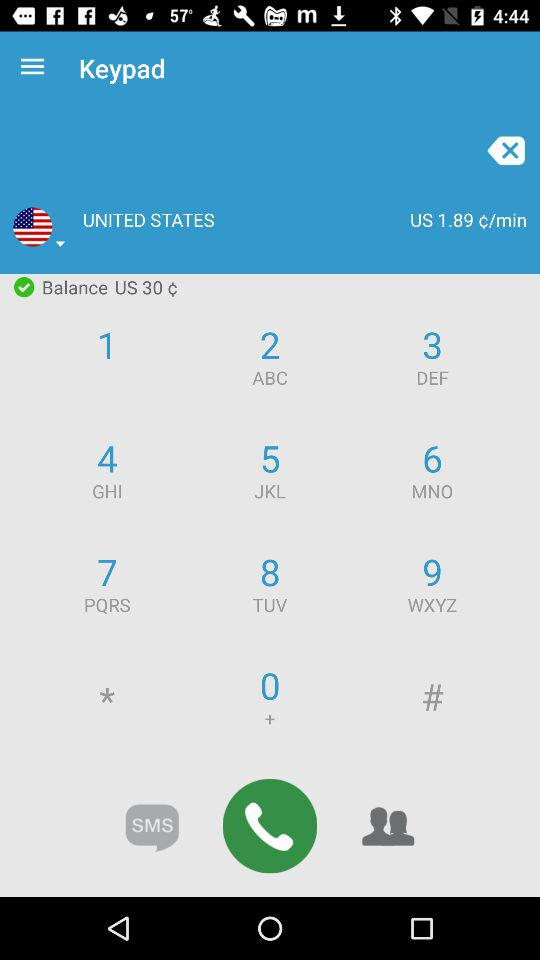What is the selected country? The selected country is the "UNITED STATES". 